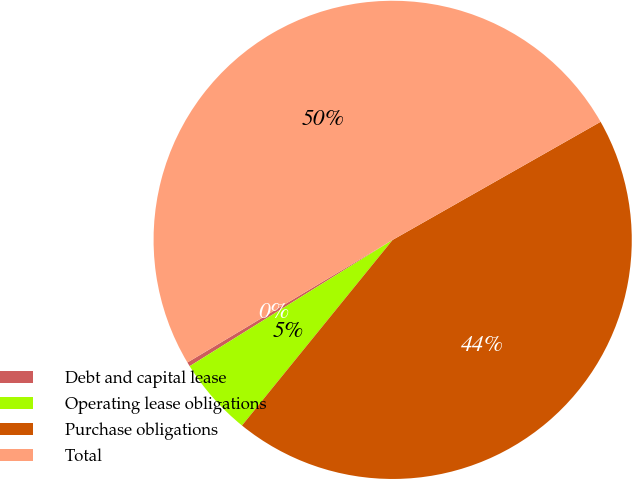Convert chart to OTSL. <chart><loc_0><loc_0><loc_500><loc_500><pie_chart><fcel>Debt and capital lease<fcel>Operating lease obligations<fcel>Purchase obligations<fcel>Total<nl><fcel>0.29%<fcel>5.29%<fcel>44.07%<fcel>50.35%<nl></chart> 